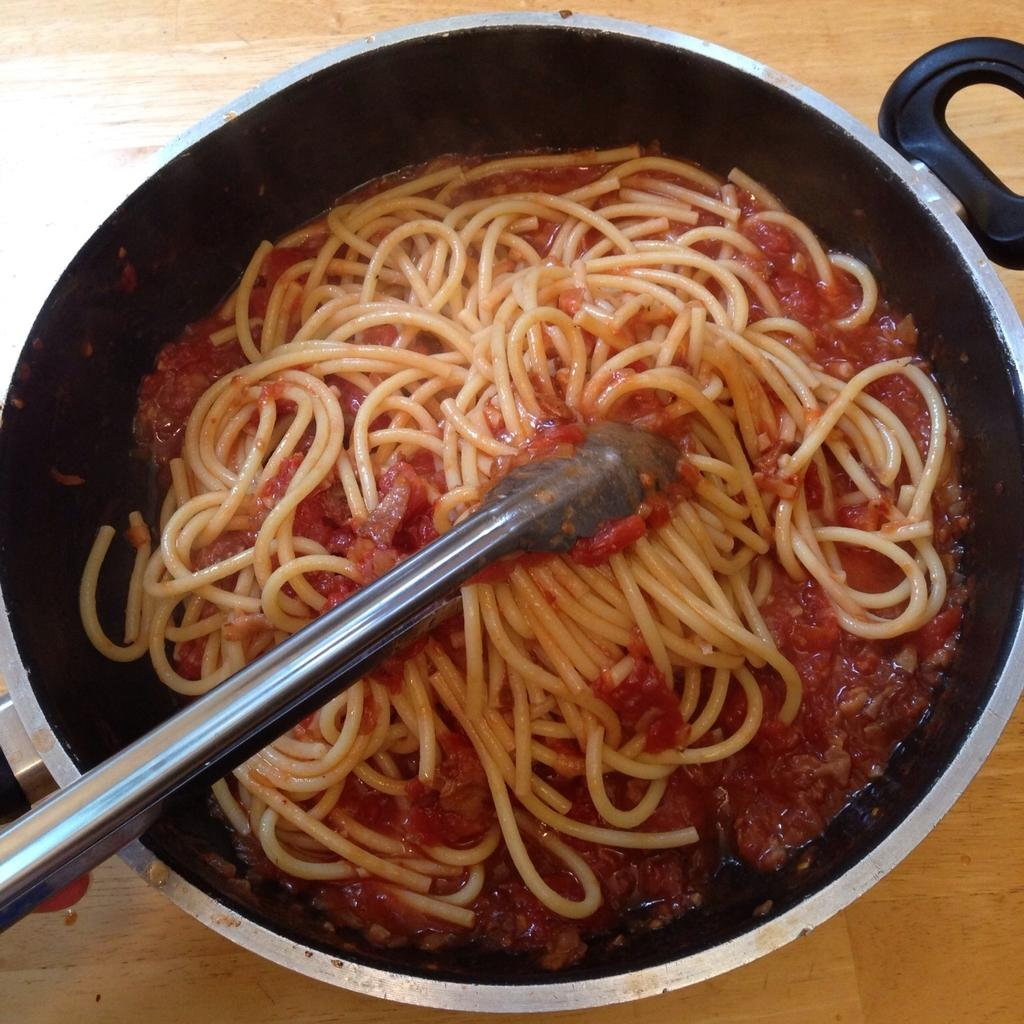What type of food is visible in the image? There are noodles with soup in the image. What cooking utensil is present in the image? A pan is present in the image. What is the pan used for? The pan contains a handler, which suggests it is being used for cooking or serving food. Where is the pan placed in the image? The pan is placed on a surface. What is the color of the background in the image? The background color is brown. Can you see a tent in the image? No, there is no tent present in the image. Is there a railway visible in the image? No, there is no railway present in the image. 